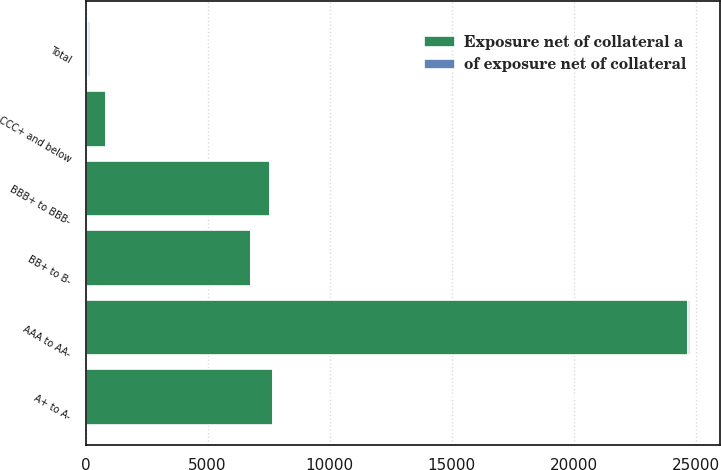Convert chart. <chart><loc_0><loc_0><loc_500><loc_500><stacked_bar_chart><ecel><fcel>AAA to AA-<fcel>A+ to A-<fcel>BBB+ to BBB-<fcel>BB+ to B-<fcel>CCC+ and below<fcel>Total<nl><fcel>Exposure net of collateral a<fcel>24697<fcel>7677<fcel>7564<fcel>6777<fcel>822<fcel>100<nl><fcel>of exposure net of collateral<fcel>52<fcel>16<fcel>16<fcel>14<fcel>2<fcel>100<nl></chart> 